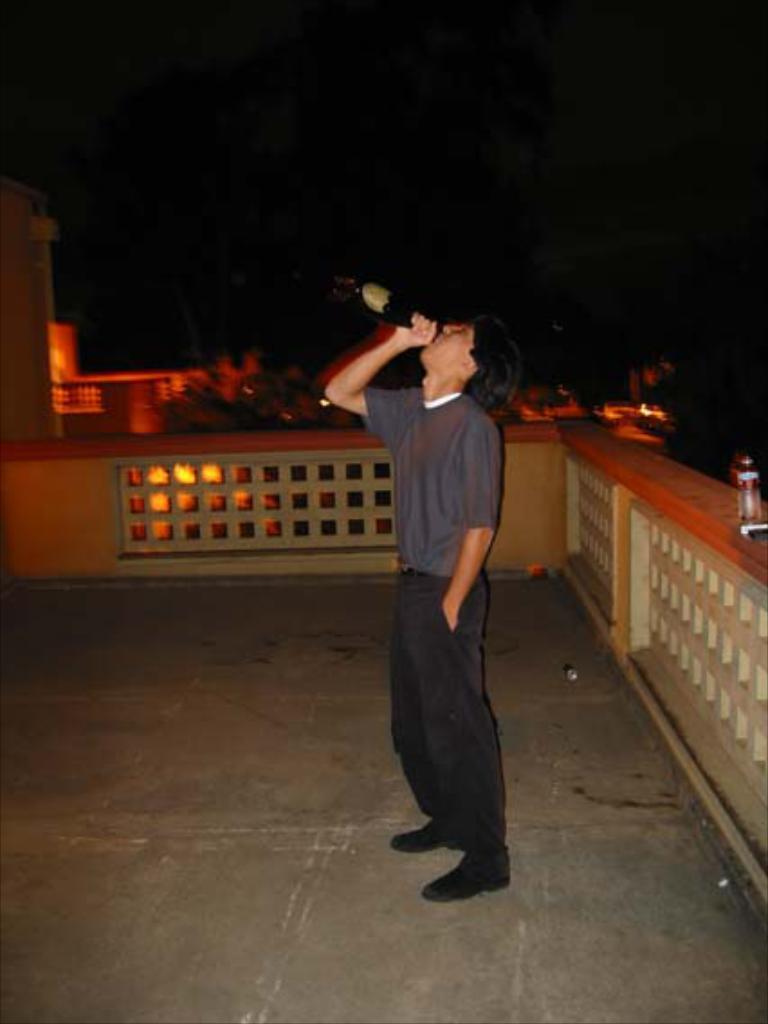Can you describe this image briefly? In the middle of this image there is a man standing facing towards the left side, holding a bottle in the hand and drinking. On the right side there is a railing. The background is dark. 